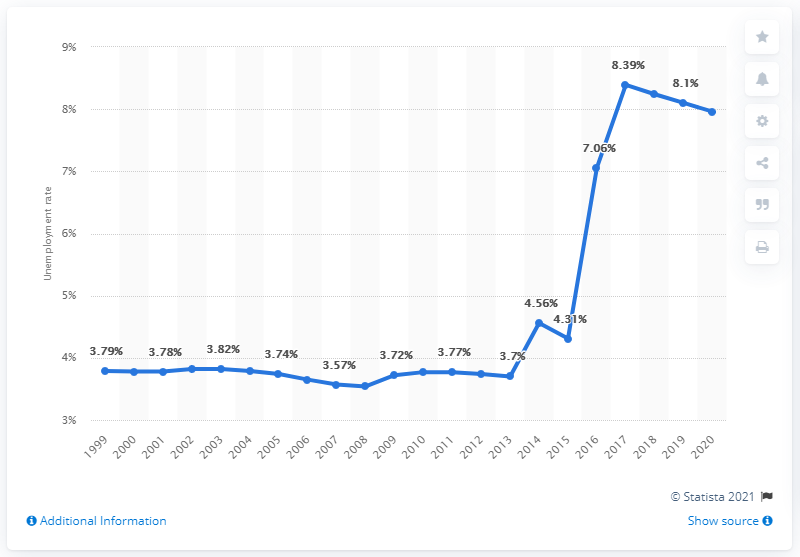Mention a couple of crucial points in this snapshot. In 2020, the unemployment rate in Nigeria was 7.96%. 